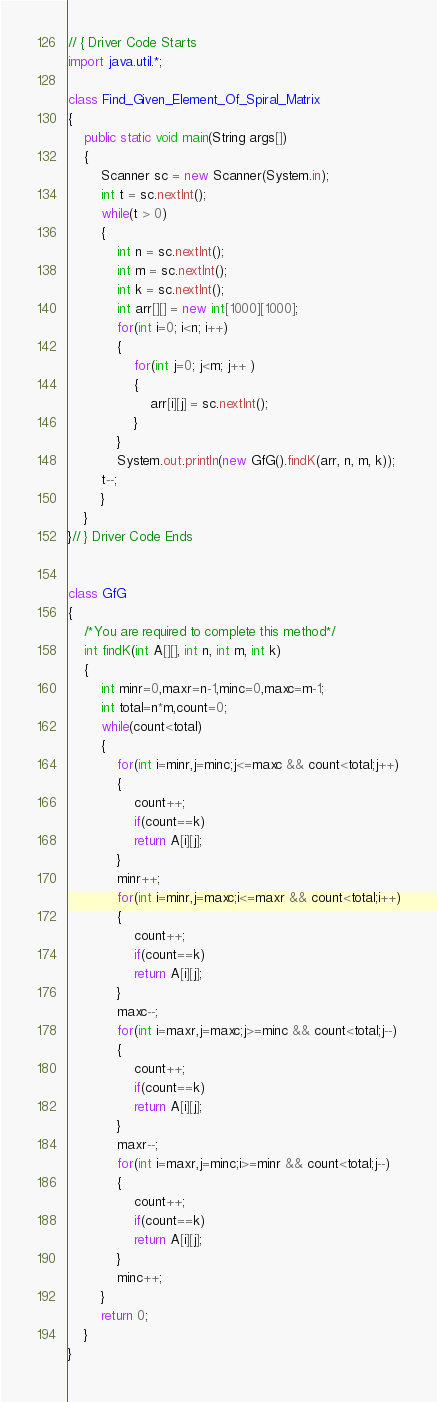Convert code to text. <code><loc_0><loc_0><loc_500><loc_500><_Java_>// { Driver Code Starts
import java.util.*;

class Find_Given_Element_Of_Spiral_Matrix 
{
	public static void main(String args[])
	{
		Scanner sc = new Scanner(System.in);
		int t = sc.nextInt();
		while(t > 0)
		{
			int n = sc.nextInt();
			int m = sc.nextInt();
			int k = sc.nextInt();
			int arr[][] = new int[1000][1000];
			for(int i=0; i<n; i++)
			{
				for(int j=0; j<m; j++ )
				{
					arr[i][j] = sc.nextInt();
				}
			}
			System.out.println(new GfG().findK(arr, n, m, k));
		t--;
		}
	}
}// } Driver Code Ends


class GfG
{
    /*You are required to complete this method*/
    int findK(int A[][], int n, int m, int k)
    {
	    int minr=0,maxr=n-1,minc=0,maxc=m-1;
	    int total=n*m,count=0;
	    while(count<total)
	    {
	        for(int i=minr,j=minc;j<=maxc && count<total;j++)
	        {
	            count++;
	            if(count==k)
	            return A[i][j];
	        }
	        minr++;
	        for(int i=minr,j=maxc;i<=maxr && count<total;i++)
	        {
	            count++;
	            if(count==k)
	            return A[i][j];
	        }
	        maxc--;
	        for(int i=maxr,j=maxc;j>=minc && count<total;j--)
	        {
	            count++;
	            if(count==k)
	            return A[i][j];
	        }
	        maxr--;
	        for(int i=maxr,j=minc;i>=minr && count<total;j--)
	        {
	            count++;
	            if(count==k)
	            return A[i][j];
	        }
	        minc++;
	    }
	    return 0;
    }
}</code> 